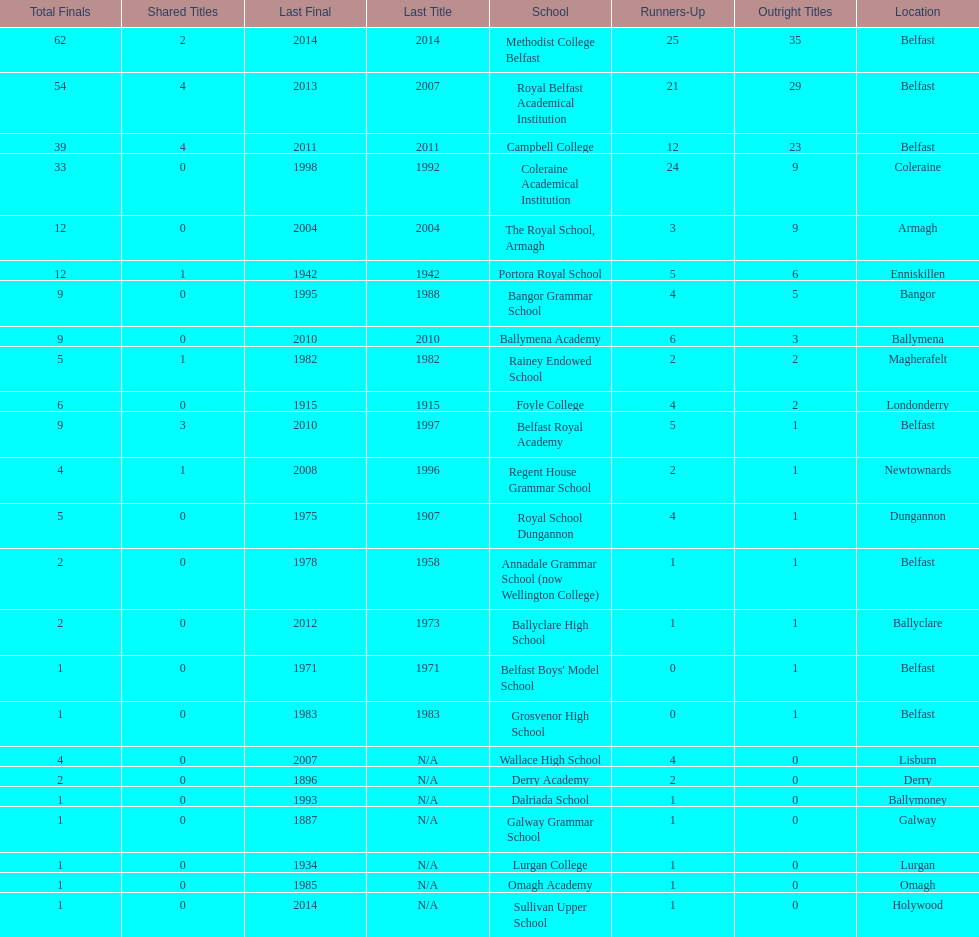Which two schools each had twelve total finals? The Royal School, Armagh, Portora Royal School. 